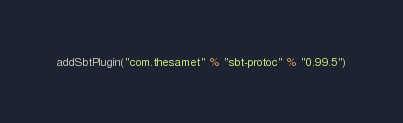Convert code to text. <code><loc_0><loc_0><loc_500><loc_500><_Scala_>addSbtPlugin("com.thesamet" % "sbt-protoc" % "0.99.5")
</code> 